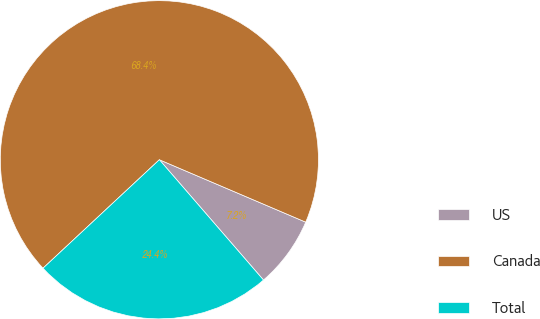Convert chart. <chart><loc_0><loc_0><loc_500><loc_500><pie_chart><fcel>US<fcel>Canada<fcel>Total<nl><fcel>7.23%<fcel>68.36%<fcel>24.41%<nl></chart> 